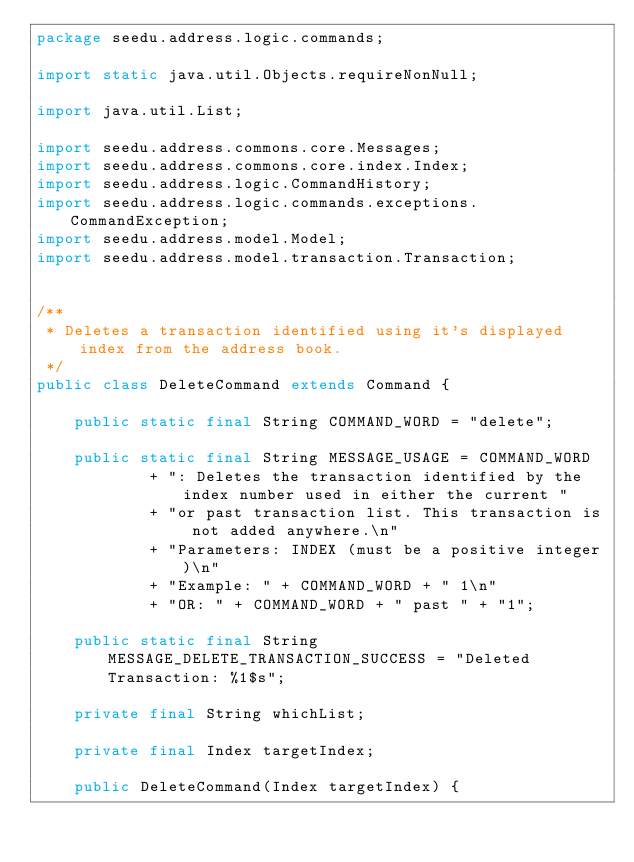Convert code to text. <code><loc_0><loc_0><loc_500><loc_500><_Java_>package seedu.address.logic.commands;

import static java.util.Objects.requireNonNull;

import java.util.List;

import seedu.address.commons.core.Messages;
import seedu.address.commons.core.index.Index;
import seedu.address.logic.CommandHistory;
import seedu.address.logic.commands.exceptions.CommandException;
import seedu.address.model.Model;
import seedu.address.model.transaction.Transaction;


/**
 * Deletes a transaction identified using it's displayed index from the address book.
 */
public class DeleteCommand extends Command {

    public static final String COMMAND_WORD = "delete";

    public static final String MESSAGE_USAGE = COMMAND_WORD
            + ": Deletes the transaction identified by the index number used in either the current "
            + "or past transaction list. This transaction is not added anywhere.\n"
            + "Parameters: INDEX (must be a positive integer)\n"
            + "Example: " + COMMAND_WORD + " 1\n"
            + "OR: " + COMMAND_WORD + " past " + "1";

    public static final String MESSAGE_DELETE_TRANSACTION_SUCCESS = "Deleted Transaction: %1$s";

    private final String whichList;

    private final Index targetIndex;

    public DeleteCommand(Index targetIndex) {</code> 